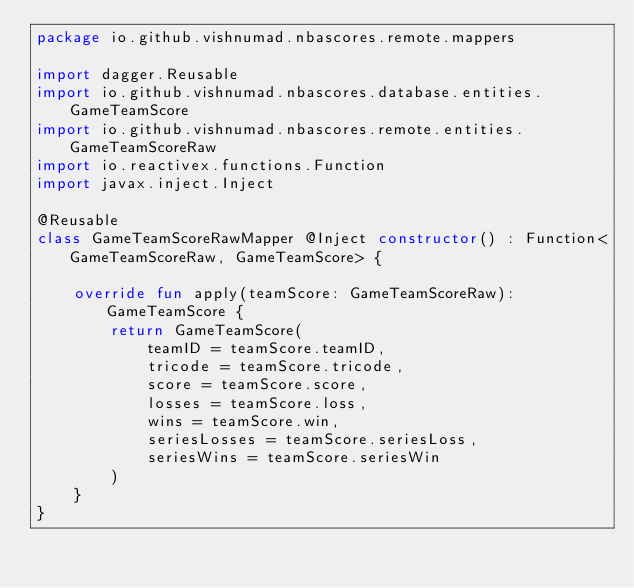Convert code to text. <code><loc_0><loc_0><loc_500><loc_500><_Kotlin_>package io.github.vishnumad.nbascores.remote.mappers

import dagger.Reusable
import io.github.vishnumad.nbascores.database.entities.GameTeamScore
import io.github.vishnumad.nbascores.remote.entities.GameTeamScoreRaw
import io.reactivex.functions.Function
import javax.inject.Inject

@Reusable
class GameTeamScoreRawMapper @Inject constructor() : Function<GameTeamScoreRaw, GameTeamScore> {

    override fun apply(teamScore: GameTeamScoreRaw): GameTeamScore {
        return GameTeamScore(
            teamID = teamScore.teamID,
            tricode = teamScore.tricode,
            score = teamScore.score,
            losses = teamScore.loss,
            wins = teamScore.win,
            seriesLosses = teamScore.seriesLoss,
            seriesWins = teamScore.seriesWin
        )
    }
}
</code> 